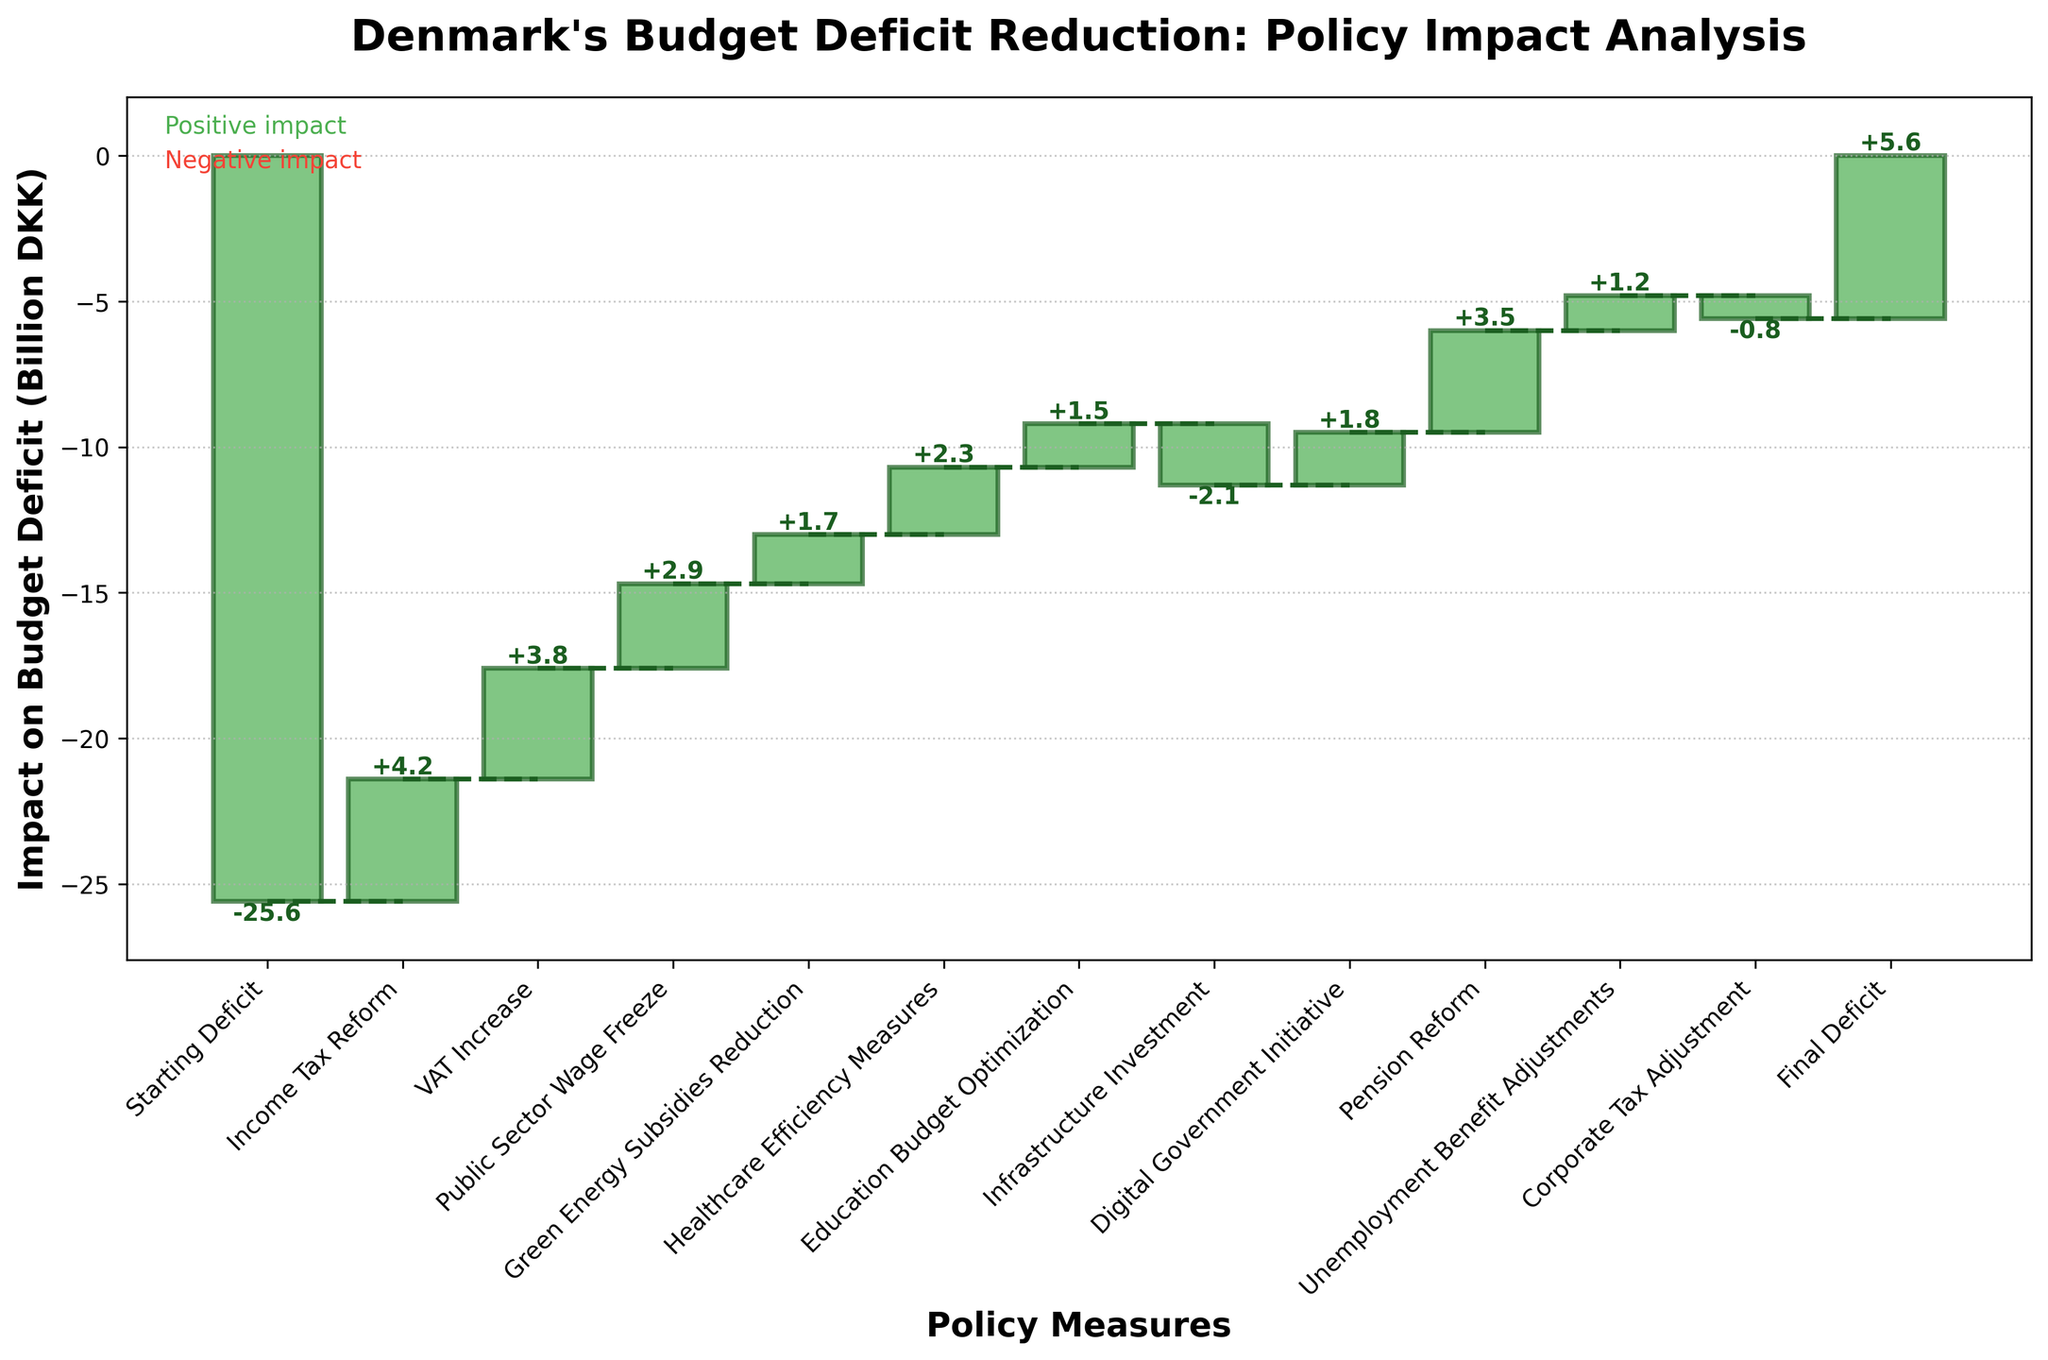What is the title of the chart? The title of the chart is written at the top and typically summarizes the subject of the chart. Here, it reads "Denmark's Budget Deficit Reduction: Policy Impact Analysis".
Answer: Denmark's Budget Deficit Reduction: Policy Impact Analysis What is the vertical axis representing in this chart? The vertical axis represents the "Impact on Budget Deficit (Billion DKK)". This indicates how each policy measure affects the budget deficit in billions of Danish kroner.
Answer: Impact on Budget Deficit (Billion DKK) How many policy measures are shown in the chart? The number of bars in the chart corresponds to the number of policy measures, including the initial and final deficit. By counting these, we can determine the total number. There are 13 categories shown.
Answer: 13 Which policy measure had the most positive impact on the budget deficit? The height of the bar indicates the impact. The policy measure with the tallest bar above the zero line has the most positive impact. Pension Reform has the highest positive impact value of 3.5 billion DKK.
Answer: Pension Reform What is the cumulative impact of the first three policy measures displayed in the chart? To find the cumulative impact, sum the values of the first three policy measures. These are: Income Tax Reform (4.2), VAT Increase (3.8), and Public Sector Wage Freeze (2.9). Adding them gives 4.2 + 3.8 + 2.9 = 10.9 billion DKK.
Answer: 10.9 billion DKK How does the impact of Infrastructure Investment compare to that of Corporate Tax Adjustment? Compare the values of the two policy measures. Infrastructure Investment has a value of -2.1 billion DKK, whereas Corporate Tax Adjustment is -0.8 billion DKK. Infrastructure Investment has a larger negative impact.
Answer: Infrastructure Investment has a larger negative impact What is the total positive impact of all the policy measures combined? Sum only the positive value impacts. These are: Income Tax Reform (4.2), VAT Increase (3.8), Public Sector Wage Freeze (2.9), Green Energy Subsidies Reduction (1.7), Healthcare Efficiency Measures (2.3), Education Budget Optimization (1.5), Digital Government Initiative (1.8), Pension Reform (3.5), and Unemployment Benefit Adjustments (1.2). The total positive impact is 4.2 + 3.8 + 2.9 + 1.7 + 2.3 + 1.5 + 1.8 + 3.5 + 1.2 = 22.9 billion DKK.
Answer: 22.9 billion DKK How did the final deficit change from the starting deficit? The starting deficit is -25.6 billion DKK, and the final deficit is 5.6 billion DKK. The change is calculated by taking the final deficit and subtracting the starting deficit: 5.6 - (-25.6) = 5.6 + 25.6 = 31.2 billion DKK. The deficit decreased by 31.2 billion DKK.
Answer: Decreased by 31.2 billion DKK Which policy measure resulted in the biggest negative impact on the budget deficit? The bar with the most negative value represents the biggest negative impact. Infrastructure Investment has the most negative impact at -2.1 billion DKK.
Answer: Infrastructure Investment What are the cumulative impacts before and after the Green Energy Subsidies Reduction policy measure? To find the cumulative impacts: 
Before: Sum the impacts of prior measures (Starting Deficit, Income Tax Reform, VAT Increase, Public Sector Wage Freeze). Their values are -25.6, 4.2, 3.8, and 2.9 respectively. 
-25.6 + 4.2 + 3.8 + 2.9 = -14.7 
After: Add Green Energy Subsidies Reduction to the cumulative sum before: 
-14.7 + 1.7 = -13.0 billion DKK. 
Thus, before: -14.7 billion DKK and after: -13.0 billion DKK.
Answer: Before: -14.7 billion DKK, After: -13.0 billion DKK 